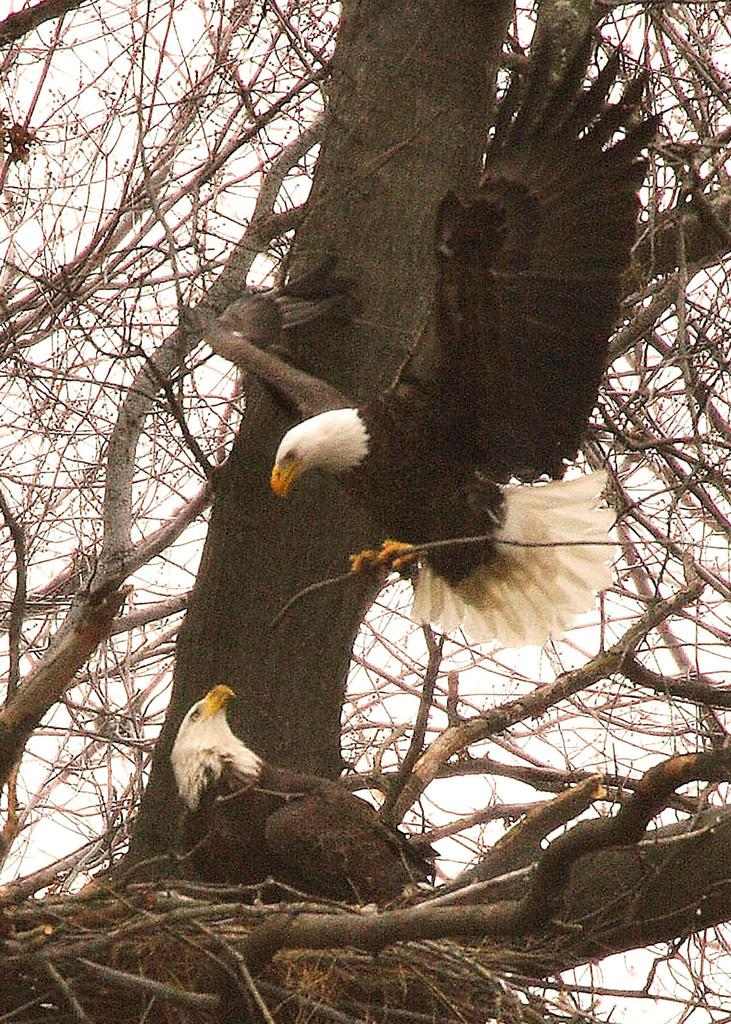What type of animals can be seen in the image? There are birds in the image. What colors are the birds in the image? The birds are in white and black color. What can be seen in the background of the image? There are dried trees and the sky visible in the background of the image. What type of flesh can be seen on the birds in the image? There is no flesh visible on the birds in the image, as they are birds and have feathers, not flesh, on their bodies. 